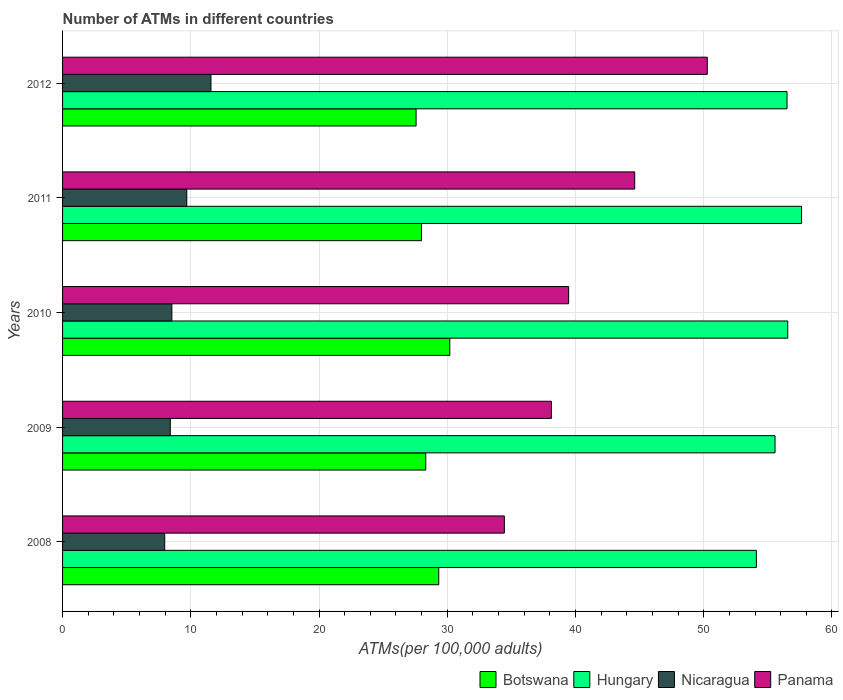How many groups of bars are there?
Offer a very short reply. 5. How many bars are there on the 3rd tick from the top?
Offer a terse response. 4. What is the label of the 2nd group of bars from the top?
Provide a succinct answer. 2011. What is the number of ATMs in Nicaragua in 2012?
Provide a short and direct response. 11.57. Across all years, what is the maximum number of ATMs in Panama?
Your answer should be very brief. 50.28. Across all years, what is the minimum number of ATMs in Nicaragua?
Your answer should be compact. 7.97. What is the total number of ATMs in Panama in the graph?
Offer a terse response. 206.93. What is the difference between the number of ATMs in Hungary in 2009 and that in 2010?
Your response must be concise. -0.99. What is the difference between the number of ATMs in Panama in 2011 and the number of ATMs in Hungary in 2008?
Your response must be concise. -9.49. What is the average number of ATMs in Nicaragua per year?
Provide a succinct answer. 9.23. In the year 2011, what is the difference between the number of ATMs in Hungary and number of ATMs in Panama?
Offer a very short reply. 13.01. What is the ratio of the number of ATMs in Nicaragua in 2009 to that in 2011?
Your answer should be very brief. 0.87. Is the difference between the number of ATMs in Hungary in 2009 and 2012 greater than the difference between the number of ATMs in Panama in 2009 and 2012?
Ensure brevity in your answer.  Yes. What is the difference between the highest and the second highest number of ATMs in Botswana?
Provide a succinct answer. 0.86. What is the difference between the highest and the lowest number of ATMs in Botswana?
Offer a very short reply. 2.63. In how many years, is the number of ATMs in Nicaragua greater than the average number of ATMs in Nicaragua taken over all years?
Provide a succinct answer. 2. What does the 2nd bar from the top in 2010 represents?
Your response must be concise. Nicaragua. What does the 2nd bar from the bottom in 2012 represents?
Make the answer very short. Hungary. Are all the bars in the graph horizontal?
Provide a succinct answer. Yes. How many years are there in the graph?
Give a very brief answer. 5. Are the values on the major ticks of X-axis written in scientific E-notation?
Provide a succinct answer. No. Does the graph contain grids?
Keep it short and to the point. Yes. Where does the legend appear in the graph?
Provide a succinct answer. Bottom right. How many legend labels are there?
Make the answer very short. 4. What is the title of the graph?
Offer a very short reply. Number of ATMs in different countries. Does "Chad" appear as one of the legend labels in the graph?
Your answer should be compact. No. What is the label or title of the X-axis?
Your answer should be compact. ATMs(per 100,0 adults). What is the ATMs(per 100,000 adults) of Botswana in 2008?
Give a very brief answer. 29.34. What is the ATMs(per 100,000 adults) of Hungary in 2008?
Your response must be concise. 54.1. What is the ATMs(per 100,000 adults) in Nicaragua in 2008?
Make the answer very short. 7.97. What is the ATMs(per 100,000 adults) in Panama in 2008?
Provide a short and direct response. 34.45. What is the ATMs(per 100,000 adults) of Botswana in 2009?
Provide a short and direct response. 28.32. What is the ATMs(per 100,000 adults) in Hungary in 2009?
Your response must be concise. 55.56. What is the ATMs(per 100,000 adults) in Nicaragua in 2009?
Provide a short and direct response. 8.4. What is the ATMs(per 100,000 adults) of Panama in 2009?
Make the answer very short. 38.12. What is the ATMs(per 100,000 adults) of Botswana in 2010?
Your answer should be very brief. 30.2. What is the ATMs(per 100,000 adults) of Hungary in 2010?
Provide a succinct answer. 56.55. What is the ATMs(per 100,000 adults) in Nicaragua in 2010?
Ensure brevity in your answer.  8.52. What is the ATMs(per 100,000 adults) of Panama in 2010?
Offer a very short reply. 39.46. What is the ATMs(per 100,000 adults) of Botswana in 2011?
Provide a succinct answer. 27.99. What is the ATMs(per 100,000 adults) of Hungary in 2011?
Give a very brief answer. 57.63. What is the ATMs(per 100,000 adults) of Nicaragua in 2011?
Your response must be concise. 9.69. What is the ATMs(per 100,000 adults) of Panama in 2011?
Keep it short and to the point. 44.62. What is the ATMs(per 100,000 adults) in Botswana in 2012?
Make the answer very short. 27.57. What is the ATMs(per 100,000 adults) in Hungary in 2012?
Offer a very short reply. 56.49. What is the ATMs(per 100,000 adults) of Nicaragua in 2012?
Ensure brevity in your answer.  11.57. What is the ATMs(per 100,000 adults) in Panama in 2012?
Provide a short and direct response. 50.28. Across all years, what is the maximum ATMs(per 100,000 adults) in Botswana?
Your response must be concise. 30.2. Across all years, what is the maximum ATMs(per 100,000 adults) in Hungary?
Offer a terse response. 57.63. Across all years, what is the maximum ATMs(per 100,000 adults) of Nicaragua?
Offer a terse response. 11.57. Across all years, what is the maximum ATMs(per 100,000 adults) of Panama?
Your response must be concise. 50.28. Across all years, what is the minimum ATMs(per 100,000 adults) of Botswana?
Offer a very short reply. 27.57. Across all years, what is the minimum ATMs(per 100,000 adults) of Hungary?
Offer a very short reply. 54.1. Across all years, what is the minimum ATMs(per 100,000 adults) in Nicaragua?
Give a very brief answer. 7.97. Across all years, what is the minimum ATMs(per 100,000 adults) in Panama?
Keep it short and to the point. 34.45. What is the total ATMs(per 100,000 adults) in Botswana in the graph?
Keep it short and to the point. 143.41. What is the total ATMs(per 100,000 adults) in Hungary in the graph?
Your answer should be compact. 280.34. What is the total ATMs(per 100,000 adults) of Nicaragua in the graph?
Provide a succinct answer. 46.15. What is the total ATMs(per 100,000 adults) of Panama in the graph?
Provide a short and direct response. 206.93. What is the difference between the ATMs(per 100,000 adults) of Botswana in 2008 and that in 2009?
Provide a succinct answer. 1.01. What is the difference between the ATMs(per 100,000 adults) of Hungary in 2008 and that in 2009?
Make the answer very short. -1.46. What is the difference between the ATMs(per 100,000 adults) of Nicaragua in 2008 and that in 2009?
Offer a very short reply. -0.43. What is the difference between the ATMs(per 100,000 adults) in Panama in 2008 and that in 2009?
Give a very brief answer. -3.67. What is the difference between the ATMs(per 100,000 adults) of Botswana in 2008 and that in 2010?
Your answer should be compact. -0.86. What is the difference between the ATMs(per 100,000 adults) in Hungary in 2008 and that in 2010?
Offer a terse response. -2.45. What is the difference between the ATMs(per 100,000 adults) of Nicaragua in 2008 and that in 2010?
Make the answer very short. -0.56. What is the difference between the ATMs(per 100,000 adults) in Panama in 2008 and that in 2010?
Your response must be concise. -5.01. What is the difference between the ATMs(per 100,000 adults) in Botswana in 2008 and that in 2011?
Ensure brevity in your answer.  1.35. What is the difference between the ATMs(per 100,000 adults) in Hungary in 2008 and that in 2011?
Your response must be concise. -3.52. What is the difference between the ATMs(per 100,000 adults) of Nicaragua in 2008 and that in 2011?
Offer a terse response. -1.72. What is the difference between the ATMs(per 100,000 adults) in Panama in 2008 and that in 2011?
Keep it short and to the point. -10.17. What is the difference between the ATMs(per 100,000 adults) in Botswana in 2008 and that in 2012?
Provide a short and direct response. 1.77. What is the difference between the ATMs(per 100,000 adults) of Hungary in 2008 and that in 2012?
Offer a very short reply. -2.39. What is the difference between the ATMs(per 100,000 adults) in Nicaragua in 2008 and that in 2012?
Provide a short and direct response. -3.61. What is the difference between the ATMs(per 100,000 adults) of Panama in 2008 and that in 2012?
Provide a succinct answer. -15.83. What is the difference between the ATMs(per 100,000 adults) in Botswana in 2009 and that in 2010?
Ensure brevity in your answer.  -1.88. What is the difference between the ATMs(per 100,000 adults) of Hungary in 2009 and that in 2010?
Offer a very short reply. -0.99. What is the difference between the ATMs(per 100,000 adults) of Nicaragua in 2009 and that in 2010?
Offer a very short reply. -0.12. What is the difference between the ATMs(per 100,000 adults) in Panama in 2009 and that in 2010?
Offer a very short reply. -1.35. What is the difference between the ATMs(per 100,000 adults) in Botswana in 2009 and that in 2011?
Your answer should be very brief. 0.33. What is the difference between the ATMs(per 100,000 adults) of Hungary in 2009 and that in 2011?
Give a very brief answer. -2.07. What is the difference between the ATMs(per 100,000 adults) in Nicaragua in 2009 and that in 2011?
Provide a succinct answer. -1.29. What is the difference between the ATMs(per 100,000 adults) in Panama in 2009 and that in 2011?
Provide a short and direct response. -6.5. What is the difference between the ATMs(per 100,000 adults) in Botswana in 2009 and that in 2012?
Make the answer very short. 0.75. What is the difference between the ATMs(per 100,000 adults) of Hungary in 2009 and that in 2012?
Your response must be concise. -0.93. What is the difference between the ATMs(per 100,000 adults) in Nicaragua in 2009 and that in 2012?
Make the answer very short. -3.17. What is the difference between the ATMs(per 100,000 adults) in Panama in 2009 and that in 2012?
Offer a very short reply. -12.16. What is the difference between the ATMs(per 100,000 adults) in Botswana in 2010 and that in 2011?
Your answer should be compact. 2.21. What is the difference between the ATMs(per 100,000 adults) in Hungary in 2010 and that in 2011?
Offer a terse response. -1.08. What is the difference between the ATMs(per 100,000 adults) in Nicaragua in 2010 and that in 2011?
Keep it short and to the point. -1.16. What is the difference between the ATMs(per 100,000 adults) of Panama in 2010 and that in 2011?
Provide a short and direct response. -5.15. What is the difference between the ATMs(per 100,000 adults) in Botswana in 2010 and that in 2012?
Keep it short and to the point. 2.63. What is the difference between the ATMs(per 100,000 adults) of Hungary in 2010 and that in 2012?
Provide a short and direct response. 0.06. What is the difference between the ATMs(per 100,000 adults) in Nicaragua in 2010 and that in 2012?
Your response must be concise. -3.05. What is the difference between the ATMs(per 100,000 adults) in Panama in 2010 and that in 2012?
Keep it short and to the point. -10.81. What is the difference between the ATMs(per 100,000 adults) in Botswana in 2011 and that in 2012?
Make the answer very short. 0.42. What is the difference between the ATMs(per 100,000 adults) of Hungary in 2011 and that in 2012?
Provide a short and direct response. 1.13. What is the difference between the ATMs(per 100,000 adults) in Nicaragua in 2011 and that in 2012?
Offer a terse response. -1.88. What is the difference between the ATMs(per 100,000 adults) of Panama in 2011 and that in 2012?
Offer a very short reply. -5.66. What is the difference between the ATMs(per 100,000 adults) in Botswana in 2008 and the ATMs(per 100,000 adults) in Hungary in 2009?
Provide a short and direct response. -26.22. What is the difference between the ATMs(per 100,000 adults) in Botswana in 2008 and the ATMs(per 100,000 adults) in Nicaragua in 2009?
Provide a succinct answer. 20.94. What is the difference between the ATMs(per 100,000 adults) in Botswana in 2008 and the ATMs(per 100,000 adults) in Panama in 2009?
Ensure brevity in your answer.  -8.78. What is the difference between the ATMs(per 100,000 adults) of Hungary in 2008 and the ATMs(per 100,000 adults) of Nicaragua in 2009?
Give a very brief answer. 45.7. What is the difference between the ATMs(per 100,000 adults) in Hungary in 2008 and the ATMs(per 100,000 adults) in Panama in 2009?
Provide a succinct answer. 15.98. What is the difference between the ATMs(per 100,000 adults) of Nicaragua in 2008 and the ATMs(per 100,000 adults) of Panama in 2009?
Keep it short and to the point. -30.15. What is the difference between the ATMs(per 100,000 adults) of Botswana in 2008 and the ATMs(per 100,000 adults) of Hungary in 2010?
Offer a terse response. -27.22. What is the difference between the ATMs(per 100,000 adults) of Botswana in 2008 and the ATMs(per 100,000 adults) of Nicaragua in 2010?
Offer a terse response. 20.81. What is the difference between the ATMs(per 100,000 adults) in Botswana in 2008 and the ATMs(per 100,000 adults) in Panama in 2010?
Give a very brief answer. -10.13. What is the difference between the ATMs(per 100,000 adults) in Hungary in 2008 and the ATMs(per 100,000 adults) in Nicaragua in 2010?
Offer a very short reply. 45.58. What is the difference between the ATMs(per 100,000 adults) in Hungary in 2008 and the ATMs(per 100,000 adults) in Panama in 2010?
Your answer should be compact. 14.64. What is the difference between the ATMs(per 100,000 adults) in Nicaragua in 2008 and the ATMs(per 100,000 adults) in Panama in 2010?
Your answer should be very brief. -31.5. What is the difference between the ATMs(per 100,000 adults) in Botswana in 2008 and the ATMs(per 100,000 adults) in Hungary in 2011?
Your response must be concise. -28.29. What is the difference between the ATMs(per 100,000 adults) of Botswana in 2008 and the ATMs(per 100,000 adults) of Nicaragua in 2011?
Provide a short and direct response. 19.65. What is the difference between the ATMs(per 100,000 adults) of Botswana in 2008 and the ATMs(per 100,000 adults) of Panama in 2011?
Provide a succinct answer. -15.28. What is the difference between the ATMs(per 100,000 adults) in Hungary in 2008 and the ATMs(per 100,000 adults) in Nicaragua in 2011?
Offer a very short reply. 44.42. What is the difference between the ATMs(per 100,000 adults) of Hungary in 2008 and the ATMs(per 100,000 adults) of Panama in 2011?
Your answer should be compact. 9.49. What is the difference between the ATMs(per 100,000 adults) in Nicaragua in 2008 and the ATMs(per 100,000 adults) in Panama in 2011?
Provide a short and direct response. -36.65. What is the difference between the ATMs(per 100,000 adults) in Botswana in 2008 and the ATMs(per 100,000 adults) in Hungary in 2012?
Provide a succinct answer. -27.16. What is the difference between the ATMs(per 100,000 adults) in Botswana in 2008 and the ATMs(per 100,000 adults) in Nicaragua in 2012?
Your response must be concise. 17.76. What is the difference between the ATMs(per 100,000 adults) of Botswana in 2008 and the ATMs(per 100,000 adults) of Panama in 2012?
Make the answer very short. -20.94. What is the difference between the ATMs(per 100,000 adults) in Hungary in 2008 and the ATMs(per 100,000 adults) in Nicaragua in 2012?
Ensure brevity in your answer.  42.53. What is the difference between the ATMs(per 100,000 adults) in Hungary in 2008 and the ATMs(per 100,000 adults) in Panama in 2012?
Ensure brevity in your answer.  3.83. What is the difference between the ATMs(per 100,000 adults) of Nicaragua in 2008 and the ATMs(per 100,000 adults) of Panama in 2012?
Your answer should be very brief. -42.31. What is the difference between the ATMs(per 100,000 adults) in Botswana in 2009 and the ATMs(per 100,000 adults) in Hungary in 2010?
Your answer should be compact. -28.23. What is the difference between the ATMs(per 100,000 adults) in Botswana in 2009 and the ATMs(per 100,000 adults) in Nicaragua in 2010?
Offer a very short reply. 19.8. What is the difference between the ATMs(per 100,000 adults) in Botswana in 2009 and the ATMs(per 100,000 adults) in Panama in 2010?
Offer a very short reply. -11.14. What is the difference between the ATMs(per 100,000 adults) in Hungary in 2009 and the ATMs(per 100,000 adults) in Nicaragua in 2010?
Your response must be concise. 47.04. What is the difference between the ATMs(per 100,000 adults) in Hungary in 2009 and the ATMs(per 100,000 adults) in Panama in 2010?
Provide a succinct answer. 16.1. What is the difference between the ATMs(per 100,000 adults) of Nicaragua in 2009 and the ATMs(per 100,000 adults) of Panama in 2010?
Your answer should be very brief. -31.06. What is the difference between the ATMs(per 100,000 adults) in Botswana in 2009 and the ATMs(per 100,000 adults) in Hungary in 2011?
Your answer should be compact. -29.31. What is the difference between the ATMs(per 100,000 adults) of Botswana in 2009 and the ATMs(per 100,000 adults) of Nicaragua in 2011?
Give a very brief answer. 18.63. What is the difference between the ATMs(per 100,000 adults) of Botswana in 2009 and the ATMs(per 100,000 adults) of Panama in 2011?
Provide a succinct answer. -16.3. What is the difference between the ATMs(per 100,000 adults) of Hungary in 2009 and the ATMs(per 100,000 adults) of Nicaragua in 2011?
Provide a short and direct response. 45.87. What is the difference between the ATMs(per 100,000 adults) in Hungary in 2009 and the ATMs(per 100,000 adults) in Panama in 2011?
Make the answer very short. 10.94. What is the difference between the ATMs(per 100,000 adults) of Nicaragua in 2009 and the ATMs(per 100,000 adults) of Panama in 2011?
Offer a terse response. -36.22. What is the difference between the ATMs(per 100,000 adults) in Botswana in 2009 and the ATMs(per 100,000 adults) in Hungary in 2012?
Offer a very short reply. -28.17. What is the difference between the ATMs(per 100,000 adults) of Botswana in 2009 and the ATMs(per 100,000 adults) of Nicaragua in 2012?
Offer a very short reply. 16.75. What is the difference between the ATMs(per 100,000 adults) of Botswana in 2009 and the ATMs(per 100,000 adults) of Panama in 2012?
Your response must be concise. -21.96. What is the difference between the ATMs(per 100,000 adults) of Hungary in 2009 and the ATMs(per 100,000 adults) of Nicaragua in 2012?
Your answer should be very brief. 43.99. What is the difference between the ATMs(per 100,000 adults) of Hungary in 2009 and the ATMs(per 100,000 adults) of Panama in 2012?
Your answer should be very brief. 5.28. What is the difference between the ATMs(per 100,000 adults) in Nicaragua in 2009 and the ATMs(per 100,000 adults) in Panama in 2012?
Your answer should be compact. -41.88. What is the difference between the ATMs(per 100,000 adults) in Botswana in 2010 and the ATMs(per 100,000 adults) in Hungary in 2011?
Provide a succinct answer. -27.43. What is the difference between the ATMs(per 100,000 adults) of Botswana in 2010 and the ATMs(per 100,000 adults) of Nicaragua in 2011?
Offer a very short reply. 20.51. What is the difference between the ATMs(per 100,000 adults) in Botswana in 2010 and the ATMs(per 100,000 adults) in Panama in 2011?
Your answer should be compact. -14.42. What is the difference between the ATMs(per 100,000 adults) in Hungary in 2010 and the ATMs(per 100,000 adults) in Nicaragua in 2011?
Ensure brevity in your answer.  46.86. What is the difference between the ATMs(per 100,000 adults) of Hungary in 2010 and the ATMs(per 100,000 adults) of Panama in 2011?
Your response must be concise. 11.93. What is the difference between the ATMs(per 100,000 adults) of Nicaragua in 2010 and the ATMs(per 100,000 adults) of Panama in 2011?
Give a very brief answer. -36.09. What is the difference between the ATMs(per 100,000 adults) of Botswana in 2010 and the ATMs(per 100,000 adults) of Hungary in 2012?
Your answer should be compact. -26.3. What is the difference between the ATMs(per 100,000 adults) of Botswana in 2010 and the ATMs(per 100,000 adults) of Nicaragua in 2012?
Your answer should be compact. 18.63. What is the difference between the ATMs(per 100,000 adults) in Botswana in 2010 and the ATMs(per 100,000 adults) in Panama in 2012?
Your answer should be very brief. -20.08. What is the difference between the ATMs(per 100,000 adults) of Hungary in 2010 and the ATMs(per 100,000 adults) of Nicaragua in 2012?
Your answer should be very brief. 44.98. What is the difference between the ATMs(per 100,000 adults) of Hungary in 2010 and the ATMs(per 100,000 adults) of Panama in 2012?
Ensure brevity in your answer.  6.27. What is the difference between the ATMs(per 100,000 adults) in Nicaragua in 2010 and the ATMs(per 100,000 adults) in Panama in 2012?
Give a very brief answer. -41.75. What is the difference between the ATMs(per 100,000 adults) in Botswana in 2011 and the ATMs(per 100,000 adults) in Hungary in 2012?
Give a very brief answer. -28.51. What is the difference between the ATMs(per 100,000 adults) of Botswana in 2011 and the ATMs(per 100,000 adults) of Nicaragua in 2012?
Offer a terse response. 16.42. What is the difference between the ATMs(per 100,000 adults) in Botswana in 2011 and the ATMs(per 100,000 adults) in Panama in 2012?
Provide a short and direct response. -22.29. What is the difference between the ATMs(per 100,000 adults) of Hungary in 2011 and the ATMs(per 100,000 adults) of Nicaragua in 2012?
Provide a short and direct response. 46.06. What is the difference between the ATMs(per 100,000 adults) in Hungary in 2011 and the ATMs(per 100,000 adults) in Panama in 2012?
Give a very brief answer. 7.35. What is the difference between the ATMs(per 100,000 adults) in Nicaragua in 2011 and the ATMs(per 100,000 adults) in Panama in 2012?
Ensure brevity in your answer.  -40.59. What is the average ATMs(per 100,000 adults) in Botswana per year?
Provide a short and direct response. 28.68. What is the average ATMs(per 100,000 adults) in Hungary per year?
Make the answer very short. 56.07. What is the average ATMs(per 100,000 adults) of Nicaragua per year?
Offer a terse response. 9.23. What is the average ATMs(per 100,000 adults) of Panama per year?
Your answer should be very brief. 41.39. In the year 2008, what is the difference between the ATMs(per 100,000 adults) in Botswana and ATMs(per 100,000 adults) in Hungary?
Ensure brevity in your answer.  -24.77. In the year 2008, what is the difference between the ATMs(per 100,000 adults) of Botswana and ATMs(per 100,000 adults) of Nicaragua?
Ensure brevity in your answer.  21.37. In the year 2008, what is the difference between the ATMs(per 100,000 adults) in Botswana and ATMs(per 100,000 adults) in Panama?
Give a very brief answer. -5.12. In the year 2008, what is the difference between the ATMs(per 100,000 adults) in Hungary and ATMs(per 100,000 adults) in Nicaragua?
Offer a terse response. 46.14. In the year 2008, what is the difference between the ATMs(per 100,000 adults) in Hungary and ATMs(per 100,000 adults) in Panama?
Your answer should be very brief. 19.65. In the year 2008, what is the difference between the ATMs(per 100,000 adults) in Nicaragua and ATMs(per 100,000 adults) in Panama?
Keep it short and to the point. -26.49. In the year 2009, what is the difference between the ATMs(per 100,000 adults) in Botswana and ATMs(per 100,000 adults) in Hungary?
Make the answer very short. -27.24. In the year 2009, what is the difference between the ATMs(per 100,000 adults) of Botswana and ATMs(per 100,000 adults) of Nicaragua?
Give a very brief answer. 19.92. In the year 2009, what is the difference between the ATMs(per 100,000 adults) in Botswana and ATMs(per 100,000 adults) in Panama?
Ensure brevity in your answer.  -9.8. In the year 2009, what is the difference between the ATMs(per 100,000 adults) of Hungary and ATMs(per 100,000 adults) of Nicaragua?
Make the answer very short. 47.16. In the year 2009, what is the difference between the ATMs(per 100,000 adults) of Hungary and ATMs(per 100,000 adults) of Panama?
Give a very brief answer. 17.44. In the year 2009, what is the difference between the ATMs(per 100,000 adults) in Nicaragua and ATMs(per 100,000 adults) in Panama?
Provide a succinct answer. -29.72. In the year 2010, what is the difference between the ATMs(per 100,000 adults) in Botswana and ATMs(per 100,000 adults) in Hungary?
Offer a terse response. -26.35. In the year 2010, what is the difference between the ATMs(per 100,000 adults) in Botswana and ATMs(per 100,000 adults) in Nicaragua?
Keep it short and to the point. 21.68. In the year 2010, what is the difference between the ATMs(per 100,000 adults) in Botswana and ATMs(per 100,000 adults) in Panama?
Keep it short and to the point. -9.27. In the year 2010, what is the difference between the ATMs(per 100,000 adults) of Hungary and ATMs(per 100,000 adults) of Nicaragua?
Keep it short and to the point. 48.03. In the year 2010, what is the difference between the ATMs(per 100,000 adults) in Hungary and ATMs(per 100,000 adults) in Panama?
Make the answer very short. 17.09. In the year 2010, what is the difference between the ATMs(per 100,000 adults) of Nicaragua and ATMs(per 100,000 adults) of Panama?
Provide a succinct answer. -30.94. In the year 2011, what is the difference between the ATMs(per 100,000 adults) in Botswana and ATMs(per 100,000 adults) in Hungary?
Provide a short and direct response. -29.64. In the year 2011, what is the difference between the ATMs(per 100,000 adults) of Botswana and ATMs(per 100,000 adults) of Nicaragua?
Provide a short and direct response. 18.3. In the year 2011, what is the difference between the ATMs(per 100,000 adults) of Botswana and ATMs(per 100,000 adults) of Panama?
Offer a terse response. -16.63. In the year 2011, what is the difference between the ATMs(per 100,000 adults) of Hungary and ATMs(per 100,000 adults) of Nicaragua?
Give a very brief answer. 47.94. In the year 2011, what is the difference between the ATMs(per 100,000 adults) in Hungary and ATMs(per 100,000 adults) in Panama?
Provide a short and direct response. 13.01. In the year 2011, what is the difference between the ATMs(per 100,000 adults) of Nicaragua and ATMs(per 100,000 adults) of Panama?
Make the answer very short. -34.93. In the year 2012, what is the difference between the ATMs(per 100,000 adults) of Botswana and ATMs(per 100,000 adults) of Hungary?
Provide a short and direct response. -28.93. In the year 2012, what is the difference between the ATMs(per 100,000 adults) of Botswana and ATMs(per 100,000 adults) of Nicaragua?
Keep it short and to the point. 16. In the year 2012, what is the difference between the ATMs(per 100,000 adults) of Botswana and ATMs(per 100,000 adults) of Panama?
Give a very brief answer. -22.71. In the year 2012, what is the difference between the ATMs(per 100,000 adults) of Hungary and ATMs(per 100,000 adults) of Nicaragua?
Give a very brief answer. 44.92. In the year 2012, what is the difference between the ATMs(per 100,000 adults) of Hungary and ATMs(per 100,000 adults) of Panama?
Provide a short and direct response. 6.22. In the year 2012, what is the difference between the ATMs(per 100,000 adults) in Nicaragua and ATMs(per 100,000 adults) in Panama?
Your answer should be very brief. -38.71. What is the ratio of the ATMs(per 100,000 adults) of Botswana in 2008 to that in 2009?
Provide a short and direct response. 1.04. What is the ratio of the ATMs(per 100,000 adults) of Hungary in 2008 to that in 2009?
Ensure brevity in your answer.  0.97. What is the ratio of the ATMs(per 100,000 adults) of Nicaragua in 2008 to that in 2009?
Keep it short and to the point. 0.95. What is the ratio of the ATMs(per 100,000 adults) of Panama in 2008 to that in 2009?
Provide a short and direct response. 0.9. What is the ratio of the ATMs(per 100,000 adults) of Botswana in 2008 to that in 2010?
Keep it short and to the point. 0.97. What is the ratio of the ATMs(per 100,000 adults) in Hungary in 2008 to that in 2010?
Give a very brief answer. 0.96. What is the ratio of the ATMs(per 100,000 adults) of Nicaragua in 2008 to that in 2010?
Make the answer very short. 0.93. What is the ratio of the ATMs(per 100,000 adults) in Panama in 2008 to that in 2010?
Your response must be concise. 0.87. What is the ratio of the ATMs(per 100,000 adults) in Botswana in 2008 to that in 2011?
Your answer should be compact. 1.05. What is the ratio of the ATMs(per 100,000 adults) in Hungary in 2008 to that in 2011?
Give a very brief answer. 0.94. What is the ratio of the ATMs(per 100,000 adults) in Nicaragua in 2008 to that in 2011?
Your answer should be very brief. 0.82. What is the ratio of the ATMs(per 100,000 adults) of Panama in 2008 to that in 2011?
Give a very brief answer. 0.77. What is the ratio of the ATMs(per 100,000 adults) of Botswana in 2008 to that in 2012?
Offer a very short reply. 1.06. What is the ratio of the ATMs(per 100,000 adults) of Hungary in 2008 to that in 2012?
Ensure brevity in your answer.  0.96. What is the ratio of the ATMs(per 100,000 adults) of Nicaragua in 2008 to that in 2012?
Ensure brevity in your answer.  0.69. What is the ratio of the ATMs(per 100,000 adults) in Panama in 2008 to that in 2012?
Offer a very short reply. 0.69. What is the ratio of the ATMs(per 100,000 adults) of Botswana in 2009 to that in 2010?
Keep it short and to the point. 0.94. What is the ratio of the ATMs(per 100,000 adults) of Hungary in 2009 to that in 2010?
Your answer should be compact. 0.98. What is the ratio of the ATMs(per 100,000 adults) in Nicaragua in 2009 to that in 2010?
Ensure brevity in your answer.  0.99. What is the ratio of the ATMs(per 100,000 adults) of Panama in 2009 to that in 2010?
Offer a very short reply. 0.97. What is the ratio of the ATMs(per 100,000 adults) in Botswana in 2009 to that in 2011?
Offer a terse response. 1.01. What is the ratio of the ATMs(per 100,000 adults) in Hungary in 2009 to that in 2011?
Offer a terse response. 0.96. What is the ratio of the ATMs(per 100,000 adults) in Nicaragua in 2009 to that in 2011?
Keep it short and to the point. 0.87. What is the ratio of the ATMs(per 100,000 adults) in Panama in 2009 to that in 2011?
Keep it short and to the point. 0.85. What is the ratio of the ATMs(per 100,000 adults) in Botswana in 2009 to that in 2012?
Offer a very short reply. 1.03. What is the ratio of the ATMs(per 100,000 adults) of Hungary in 2009 to that in 2012?
Your response must be concise. 0.98. What is the ratio of the ATMs(per 100,000 adults) of Nicaragua in 2009 to that in 2012?
Keep it short and to the point. 0.73. What is the ratio of the ATMs(per 100,000 adults) in Panama in 2009 to that in 2012?
Provide a short and direct response. 0.76. What is the ratio of the ATMs(per 100,000 adults) of Botswana in 2010 to that in 2011?
Keep it short and to the point. 1.08. What is the ratio of the ATMs(per 100,000 adults) in Hungary in 2010 to that in 2011?
Make the answer very short. 0.98. What is the ratio of the ATMs(per 100,000 adults) in Nicaragua in 2010 to that in 2011?
Make the answer very short. 0.88. What is the ratio of the ATMs(per 100,000 adults) of Panama in 2010 to that in 2011?
Offer a very short reply. 0.88. What is the ratio of the ATMs(per 100,000 adults) in Botswana in 2010 to that in 2012?
Ensure brevity in your answer.  1.1. What is the ratio of the ATMs(per 100,000 adults) in Nicaragua in 2010 to that in 2012?
Provide a short and direct response. 0.74. What is the ratio of the ATMs(per 100,000 adults) of Panama in 2010 to that in 2012?
Ensure brevity in your answer.  0.78. What is the ratio of the ATMs(per 100,000 adults) in Botswana in 2011 to that in 2012?
Keep it short and to the point. 1.02. What is the ratio of the ATMs(per 100,000 adults) of Hungary in 2011 to that in 2012?
Your response must be concise. 1.02. What is the ratio of the ATMs(per 100,000 adults) in Nicaragua in 2011 to that in 2012?
Keep it short and to the point. 0.84. What is the ratio of the ATMs(per 100,000 adults) of Panama in 2011 to that in 2012?
Offer a terse response. 0.89. What is the difference between the highest and the second highest ATMs(per 100,000 adults) of Botswana?
Keep it short and to the point. 0.86. What is the difference between the highest and the second highest ATMs(per 100,000 adults) of Hungary?
Your answer should be compact. 1.08. What is the difference between the highest and the second highest ATMs(per 100,000 adults) in Nicaragua?
Offer a terse response. 1.88. What is the difference between the highest and the second highest ATMs(per 100,000 adults) of Panama?
Offer a very short reply. 5.66. What is the difference between the highest and the lowest ATMs(per 100,000 adults) in Botswana?
Keep it short and to the point. 2.63. What is the difference between the highest and the lowest ATMs(per 100,000 adults) in Hungary?
Keep it short and to the point. 3.52. What is the difference between the highest and the lowest ATMs(per 100,000 adults) in Nicaragua?
Ensure brevity in your answer.  3.61. What is the difference between the highest and the lowest ATMs(per 100,000 adults) of Panama?
Offer a terse response. 15.83. 